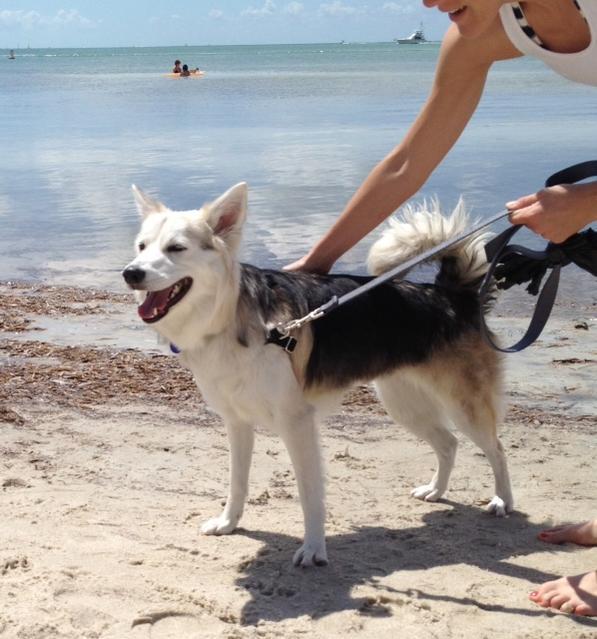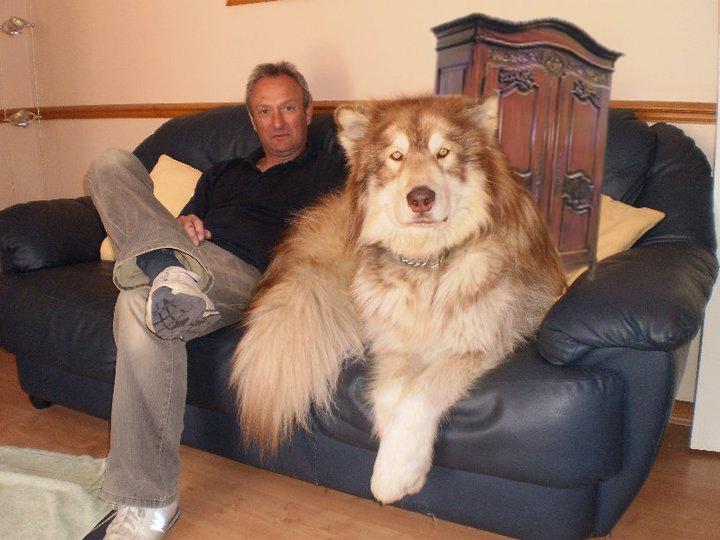The first image is the image on the left, the second image is the image on the right. For the images displayed, is the sentence "In one of the images, a Malamute is near a man who is sitting on a couch." factually correct? Answer yes or no. Yes. The first image is the image on the left, the second image is the image on the right. Analyze the images presented: Is the assertion "One image shows a single dog standing in profile, and the other image shows a man sitting on an overstuffed couch near a big dog." valid? Answer yes or no. Yes. 